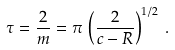<formula> <loc_0><loc_0><loc_500><loc_500>\tau = \frac { 2 } { m } = \pi \, \left ( \frac { 2 } { c - R } \right ) ^ { 1 / 2 } \, .</formula> 